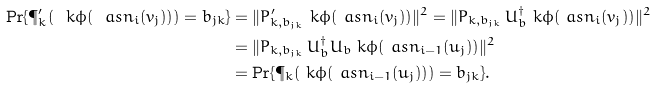<formula> <loc_0><loc_0><loc_500><loc_500>\Pr \{ \P _ { k } ^ { \prime } ( \ k { \phi ( \ a s n _ { i } ( v _ { j } ) ) } ) = b _ { j k } \} & = \| P _ { k , b _ { j k } } ^ { \prime } \ k { \phi ( \ a s n _ { i } ( v _ { j } ) ) } \| ^ { 2 } = \| P _ { k , b _ { j k } } \, U _ { b } ^ { \dag } \ k { \phi ( \ a s n _ { i } ( v _ { j } ) ) } \| ^ { 2 } \\ & = \| P _ { k , b _ { j k } } \, U _ { b } ^ { \dag } U _ { b } \ k { \phi ( \ a s n _ { i - 1 } ( u _ { j } ) ) } \| ^ { 2 } \\ & = \Pr \{ \P _ { k } ( \ k { \phi ( \ a s n _ { i - 1 } ( u _ { j } ) ) } ) = b _ { j k } \} .</formula> 